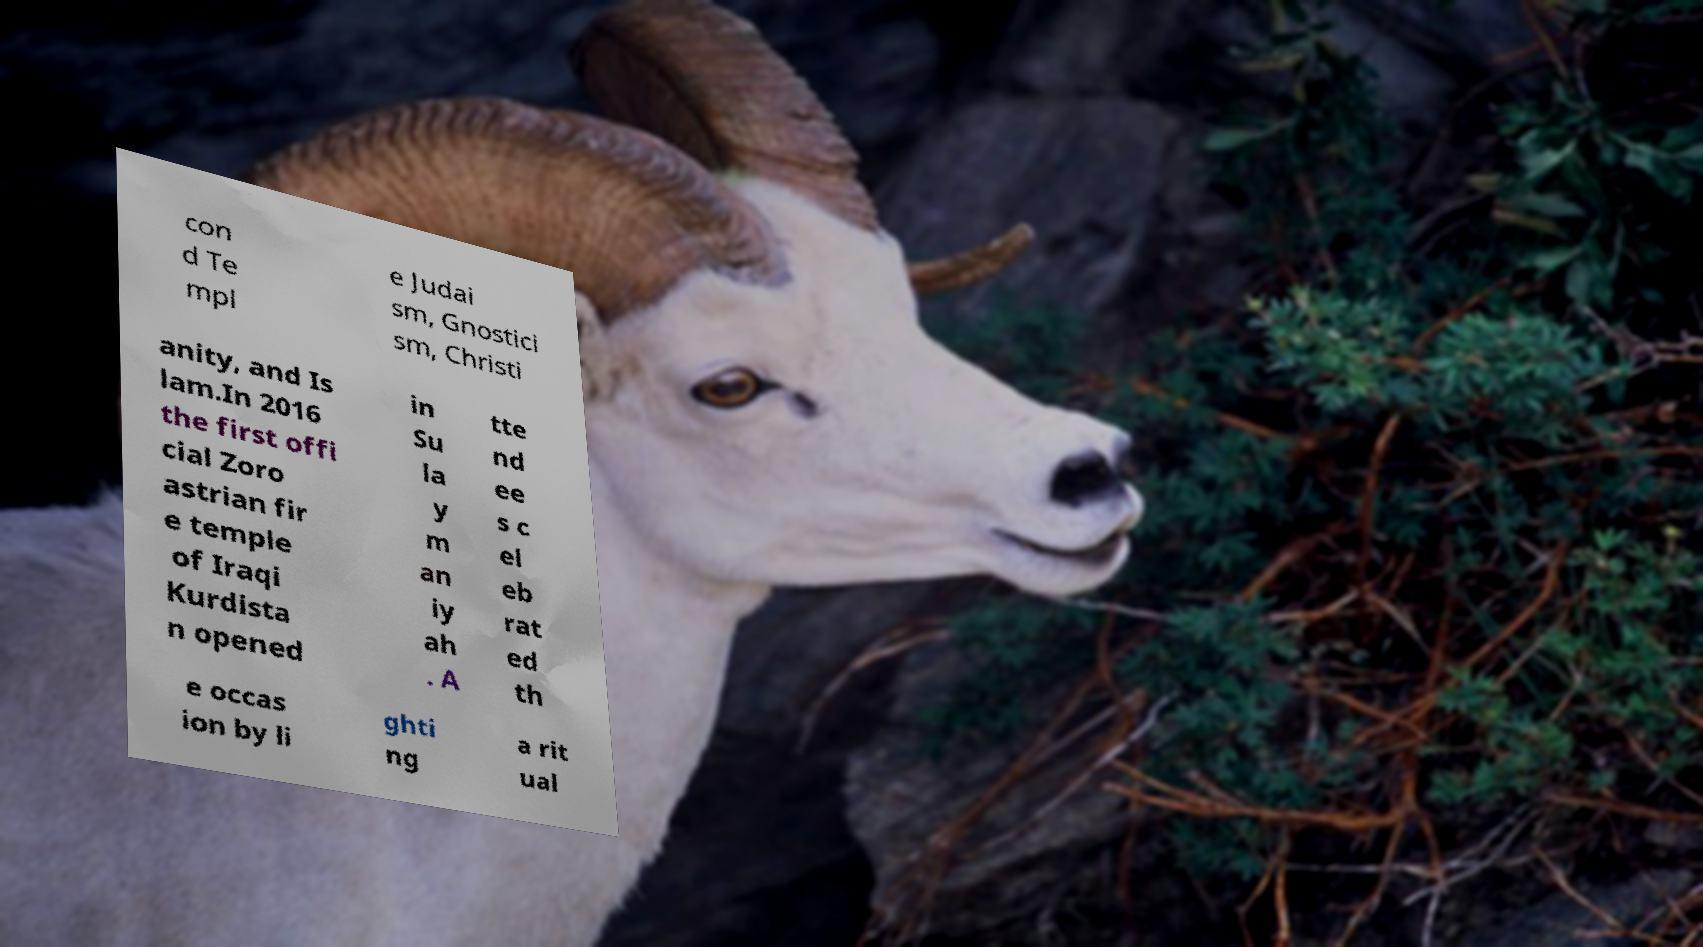Could you assist in decoding the text presented in this image and type it out clearly? con d Te mpl e Judai sm, Gnostici sm, Christi anity, and Is lam.In 2016 the first offi cial Zoro astrian fir e temple of Iraqi Kurdista n opened in Su la y m an iy ah . A tte nd ee s c el eb rat ed th e occas ion by li ghti ng a rit ual 